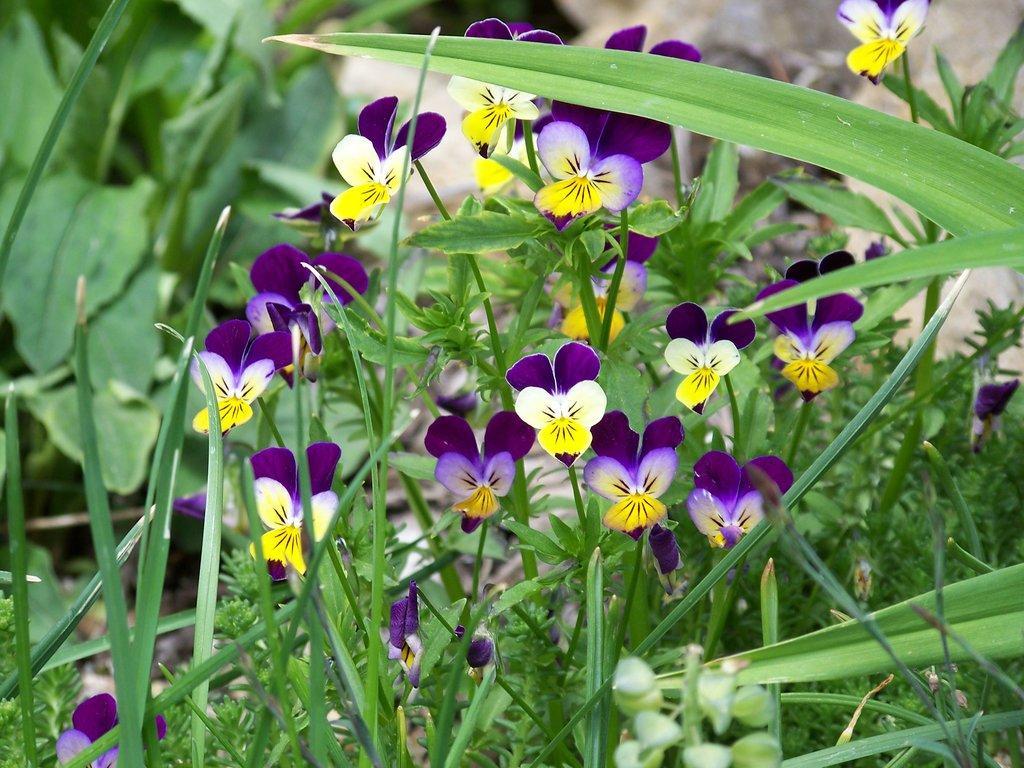Describe this image in one or two sentences. In this image, we can see some plants with flowers. 